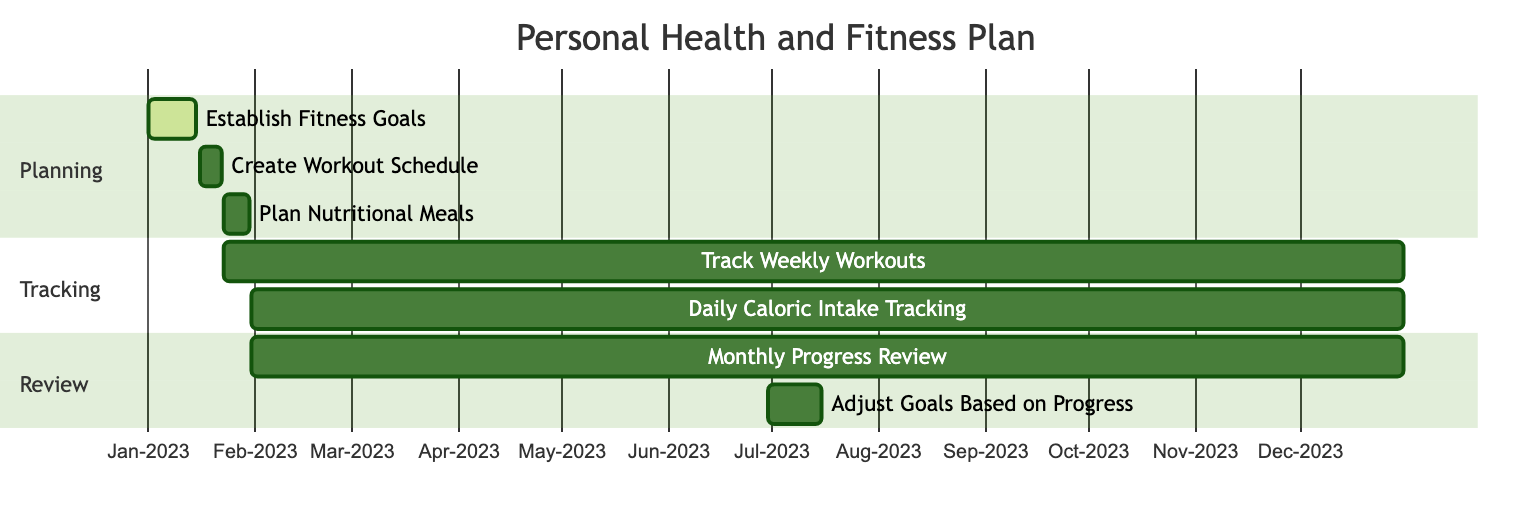What is the duration of the "Establish Fitness Goals" task? The "Establish Fitness Goals" task starts on January 1, 2023, and ends on January 15, 2023. Therefore, the duration is the difference between these two dates: 15 days.
Answer: 15 days How many tasks are under the "Tracking" section? The "Tracking" section includes two tasks: "Track Weekly Workouts" and "Daily Caloric Intake Tracking." Therefore, there are 2 tasks in this section.
Answer: 2 tasks Which task starts immediately after "Plan Nutritional Meals"? "Track Weekly Workouts" starts on January 23, 2023, which is immediately after "Plan Nutritional Meals" that ends on January 30, 2023.
Answer: Track Weekly Workouts When is the "Adjust Goals Based on Progress" task scheduled to take place? The "Adjust Goals Based on Progress" task is scheduled to start on June 30, 2023, and end on July 15, 2023. Thus, it takes place during this timeframe specifically in July 2023.
Answer: June 30 to July 15 What task overlaps with "Monthly Progress Review"? "Daily Caloric Intake Tracking" overlaps with "Monthly Progress Review" as both tasks run from January 31, 2023, to December 31, 2023. Overlapping means they share the same time period.
Answer: Daily Caloric Intake Tracking How many total tasks are in the Gantt chart? Upon examining the tasks, there are a total of 7 tasks listed in the Gantt chart concerning the personal health and fitness plan. Therefore, the overall count of tasks is 7.
Answer: 7 tasks Which task is active during the entire year of 2023? The task "Track Weekly Workouts" is active throughout the entire year as it spans from January 23, 2023, to December 31, 2023. This confirms its full annual duration.
Answer: Track Weekly Workouts What is the start date of the "Create Workout Schedule" task? The "Create Workout Schedule" task starts on January 16, 2023. This date is clearly noted in the task's timeline.
Answer: January 16, 2023 